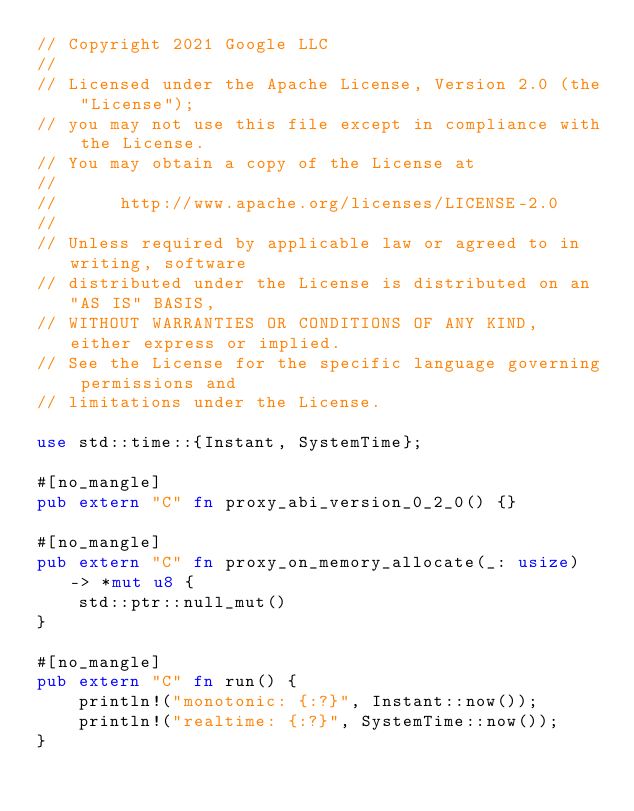<code> <loc_0><loc_0><loc_500><loc_500><_Rust_>// Copyright 2021 Google LLC
//
// Licensed under the Apache License, Version 2.0 (the "License");
// you may not use this file except in compliance with the License.
// You may obtain a copy of the License at
//
//      http://www.apache.org/licenses/LICENSE-2.0
//
// Unless required by applicable law or agreed to in writing, software
// distributed under the License is distributed on an "AS IS" BASIS,
// WITHOUT WARRANTIES OR CONDITIONS OF ANY KIND, either express or implied.
// See the License for the specific language governing permissions and
// limitations under the License.

use std::time::{Instant, SystemTime};

#[no_mangle]
pub extern "C" fn proxy_abi_version_0_2_0() {}

#[no_mangle]
pub extern "C" fn proxy_on_memory_allocate(_: usize) -> *mut u8 {
    std::ptr::null_mut()
}

#[no_mangle]
pub extern "C" fn run() {
    println!("monotonic: {:?}", Instant::now());
    println!("realtime: {:?}", SystemTime::now());
}
</code> 